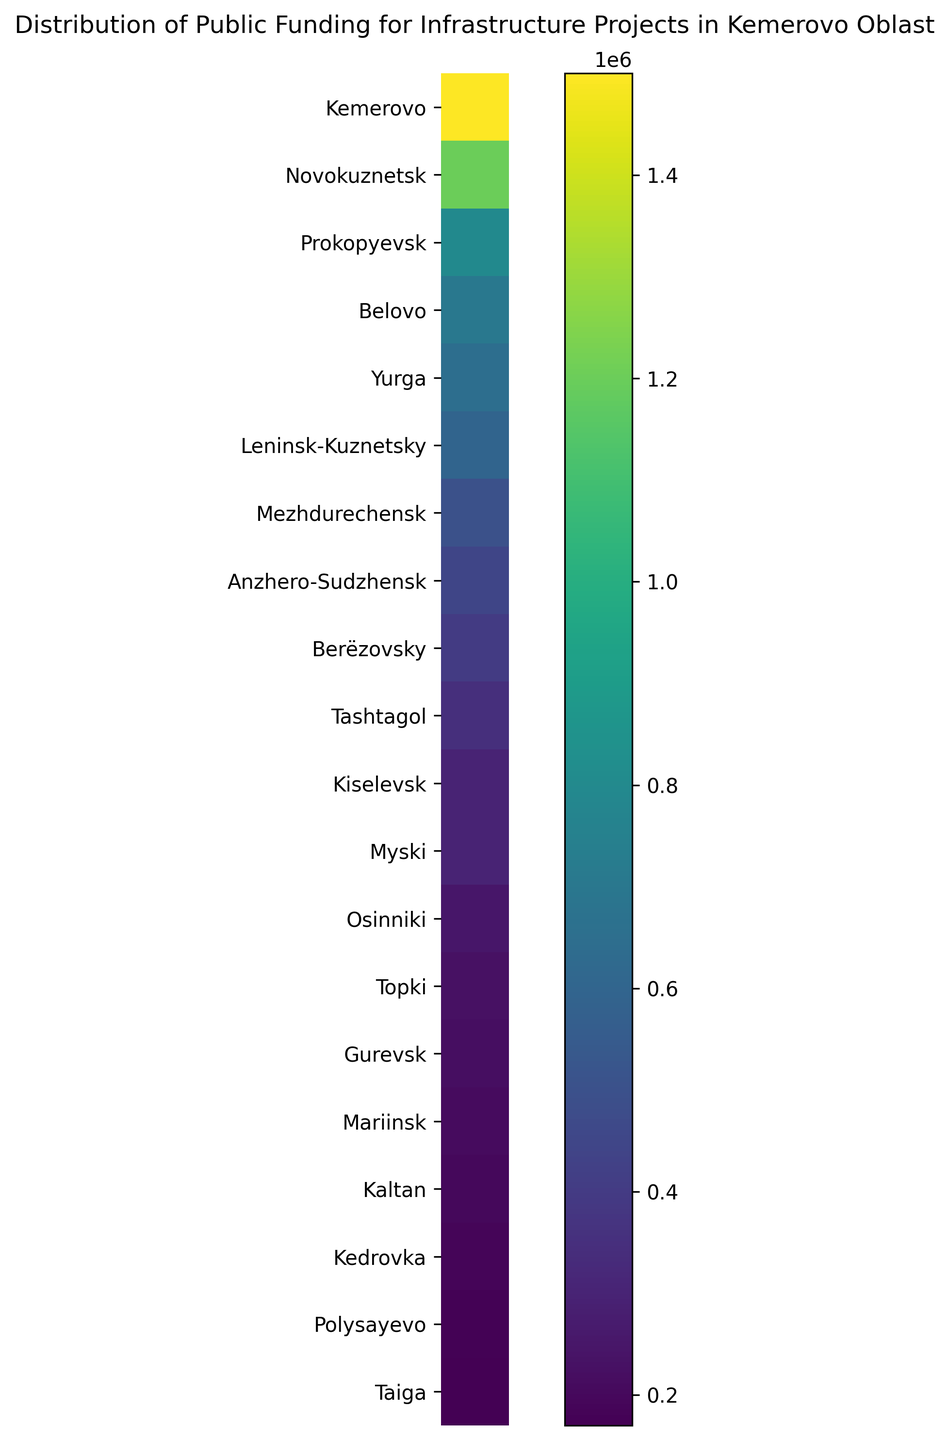What is the total funding for Mezhdurechensk and Berëzovsky? To find the total funding for Mezhdurechensk and Berëzovsky, add their respective funding amounts: 500,000 (Mezhdurechensk) + 400,000 (Berëzovsky) = 900,000
Answer: 900,000 Which municipality received the least amount of funding? The municipality with the darkest color on the heatmap indicates the least amount of funding. From the data, Polysayevo has the lowest funding amount of 180,000
Answer: Polysayevo How does the funding for Anzhero-Sudzhensk compare to that of Kiselevsk? Anzhero-Sudzhensk received 450,000 while Kiselevsk received 300,000. Thus, Anzhero-Sudzhensk received more funding than Kiselevsk.
Answer: Anzhero-Sudzhensk received more What is the average funding amount for the municipalities with funding above 1,000,000? The municipalities with funding above 1,000,000 are Kemerovo (1,500,000) and Novokuznetsk (1,200,000). Average = (1,500,000 + 1,200,000) / 2 = 1,350,000
Answer: 1,350,000 Which municipality received funding closest to 500,000? By comparing the funding amounts close to this value, Mezhdurechensk received exactly 500,000, which is closest to the given value
Answer: Mezhdurechensk What is the difference in funding between the highest and the lowest funded municipalities? The highest funded municipality is Kemerovo (1,500,000), and the lowest funded is Polysayevo (180,000). Difference = 1,500,000 - 180,000 = 1,320,000
Answer: 1,320,000 How many municipalities received less than 500,000 in funding? Count the municipalities with funding amounts below 500,000: Kiselevsk, Tashtagol, Berëzovsky, Myski, Osinniki, Kaltan, Gurevsk, Polysayevo, Taiga, Topki, Mariinsk, and Kedrovka. Total: 12
Answer: 12 